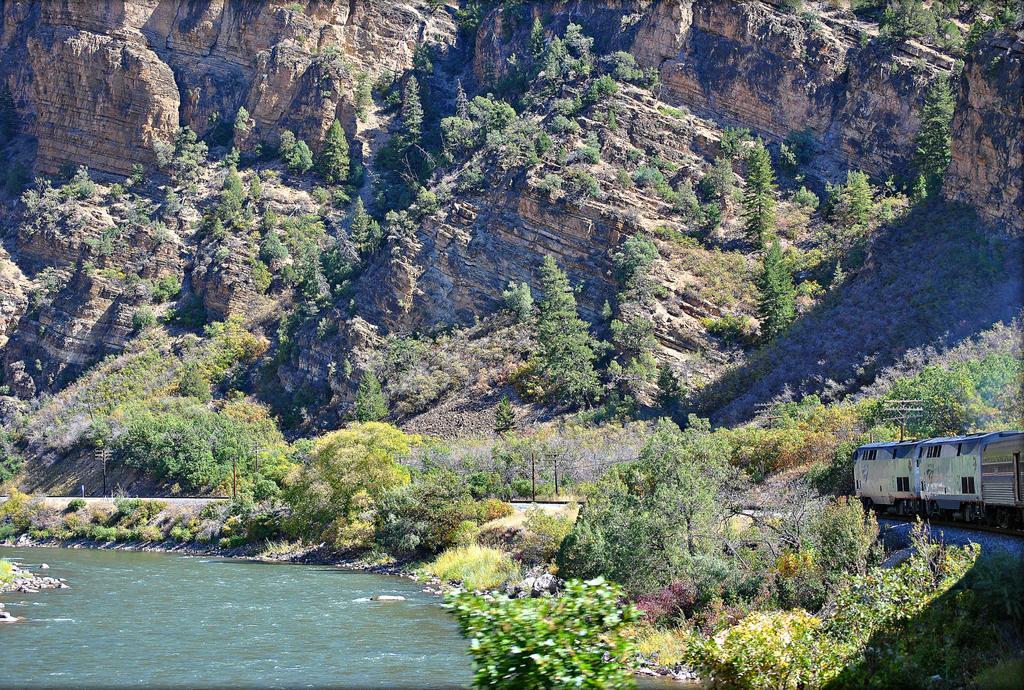How would you summarize this image in a sentence or two? This is an outdoor picture. The train is on a train track. Number of trees in green color. This is a river with a fresh water. This is a mountain. 